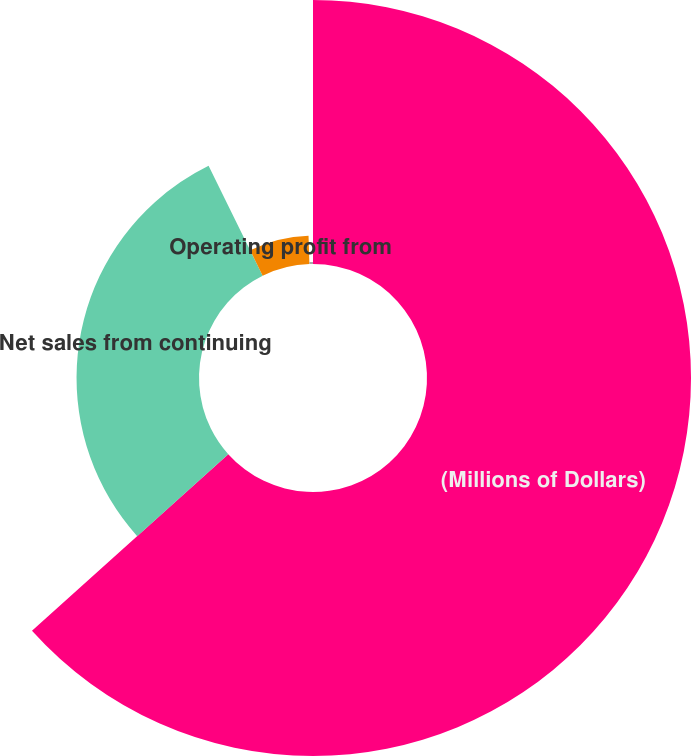<chart> <loc_0><loc_0><loc_500><loc_500><pie_chart><fcel>(Millions of Dollars)<fcel>Net sales from continuing<fcel>Operating profit from<fcel>of Net sales<nl><fcel>63.34%<fcel>29.38%<fcel>6.78%<fcel>0.5%<nl></chart> 